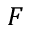<formula> <loc_0><loc_0><loc_500><loc_500>F</formula> 